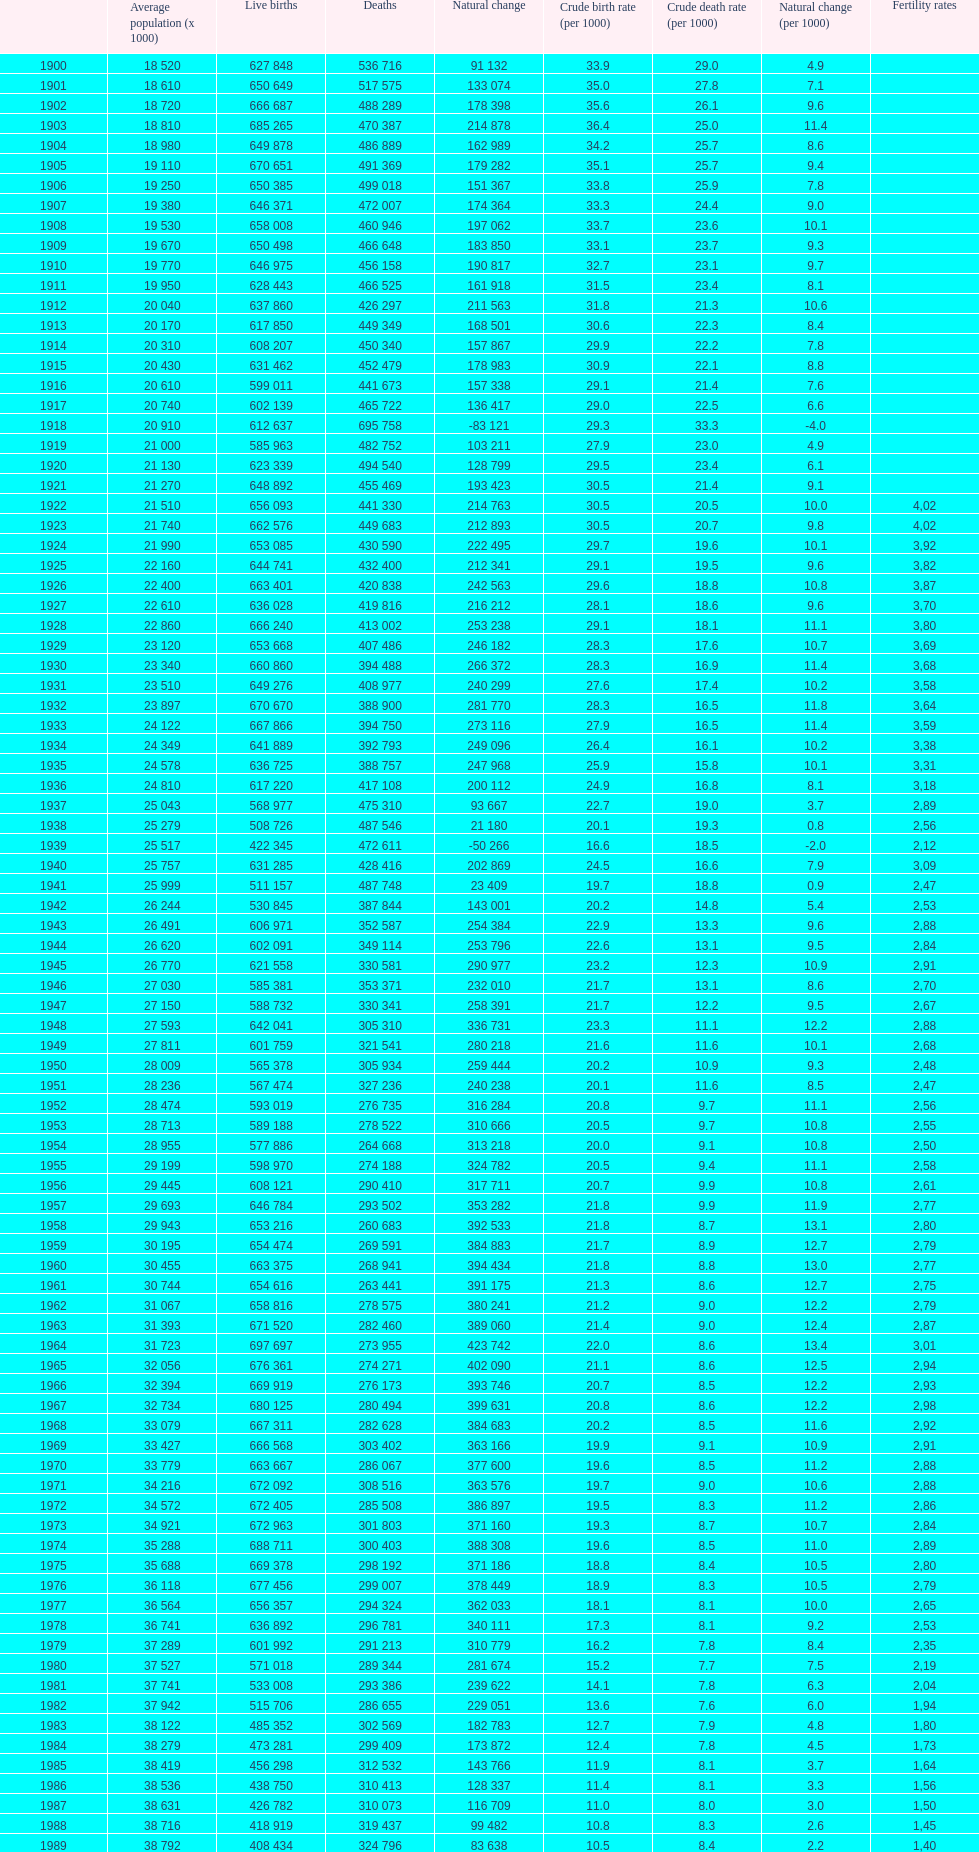1 occur with a population of 22,860? 1928. 